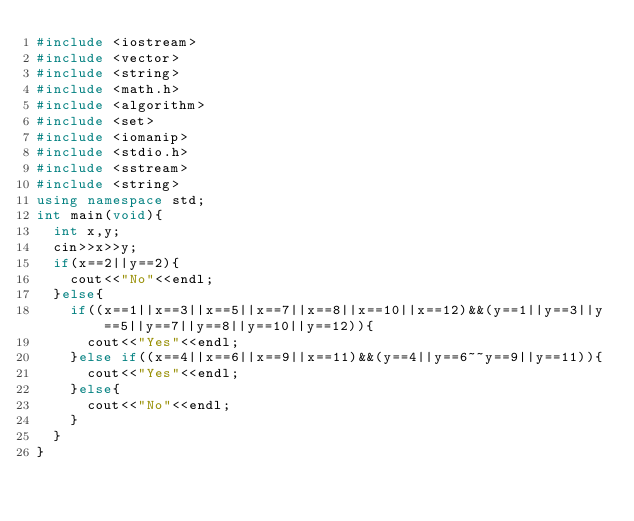Convert code to text. <code><loc_0><loc_0><loc_500><loc_500><_C++_>#include <iostream>
#include <vector>
#include <string>
#include <math.h>
#include <algorithm>
#include <set>
#include <iomanip>
#include <stdio.h>
#include <sstream>
#include <string>
using namespace std;
int main(void){
  int x,y;
  cin>>x>>y;
  if(x==2||y==2){
    cout<<"No"<<endl;
  }else{
    if((x==1||x==3||x==5||x==7||x==8||x==10||x==12)&&(y==1||y==3||y==5||y==7||y==8||y==10||y==12)){
      cout<<"Yes"<<endl;
    }else if((x==4||x==6||x==9||x==11)&&(y==4||y==6~~y==9||y==11)){
      cout<<"Yes"<<endl;
    }else{
      cout<<"No"<<endl;
    }
  }
}</code> 